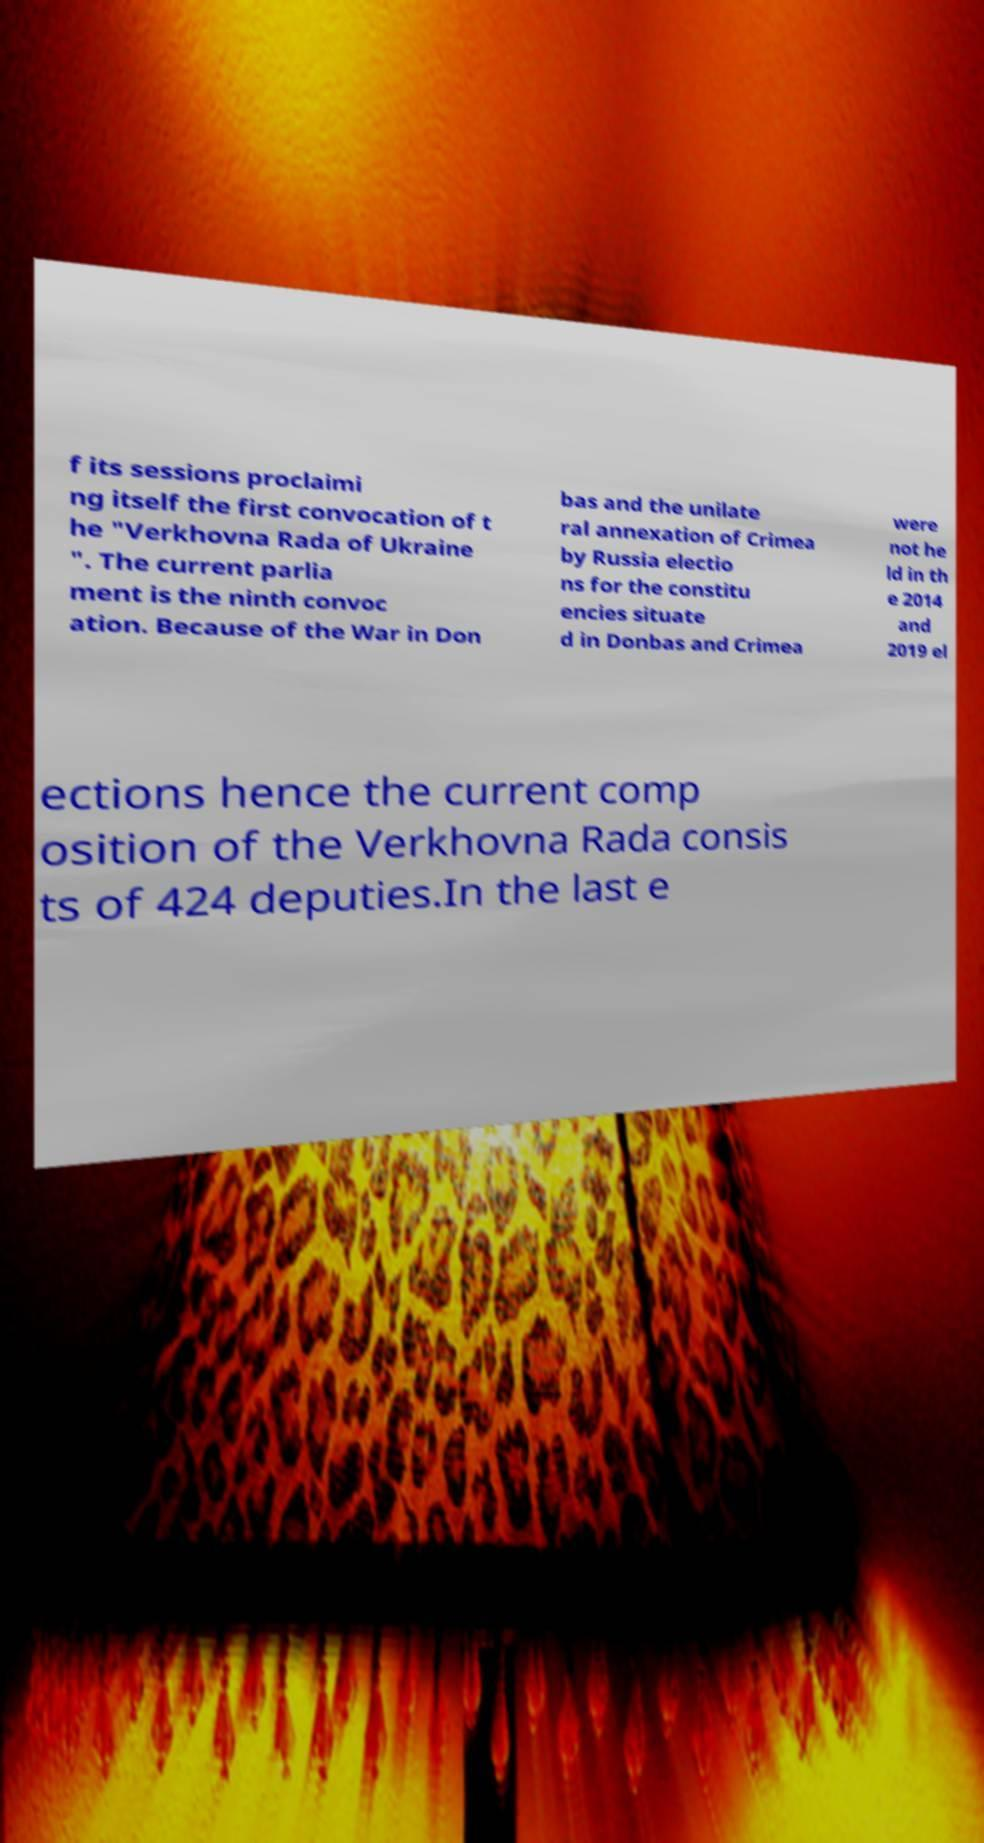There's text embedded in this image that I need extracted. Can you transcribe it verbatim? f its sessions proclaimi ng itself the first convocation of t he "Verkhovna Rada of Ukraine ". The current parlia ment is the ninth convoc ation. Because of the War in Don bas and the unilate ral annexation of Crimea by Russia electio ns for the constitu encies situate d in Donbas and Crimea were not he ld in th e 2014 and 2019 el ections hence the current comp osition of the Verkhovna Rada consis ts of 424 deputies.In the last e 